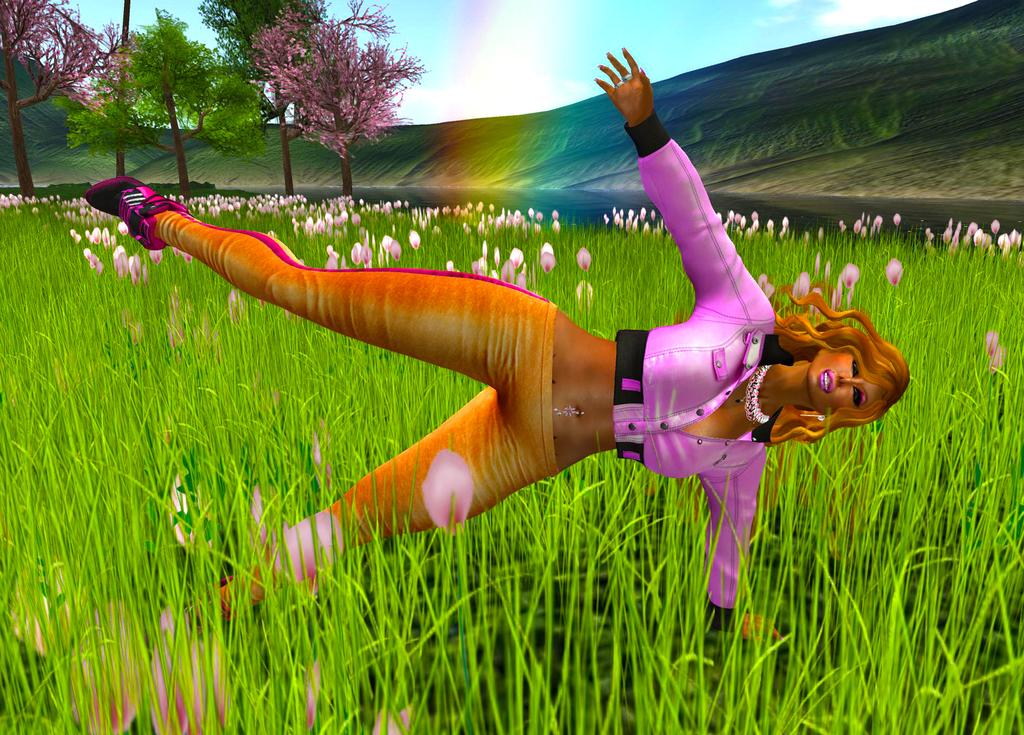What type of picture is in the image? The image contains an animated picture of a woman. What is the woman standing on? The woman is standing on grass. What can be seen in the sky in the image? The sky is visible in the image. What is in the background of the image? There are trees and a hill in the background of the image. What type of medical advice is the woman giving in the image? The image does not depict the woman giving any medical advice, as it is an animated picture of a woman standing on grass with trees and a hill in the background. 